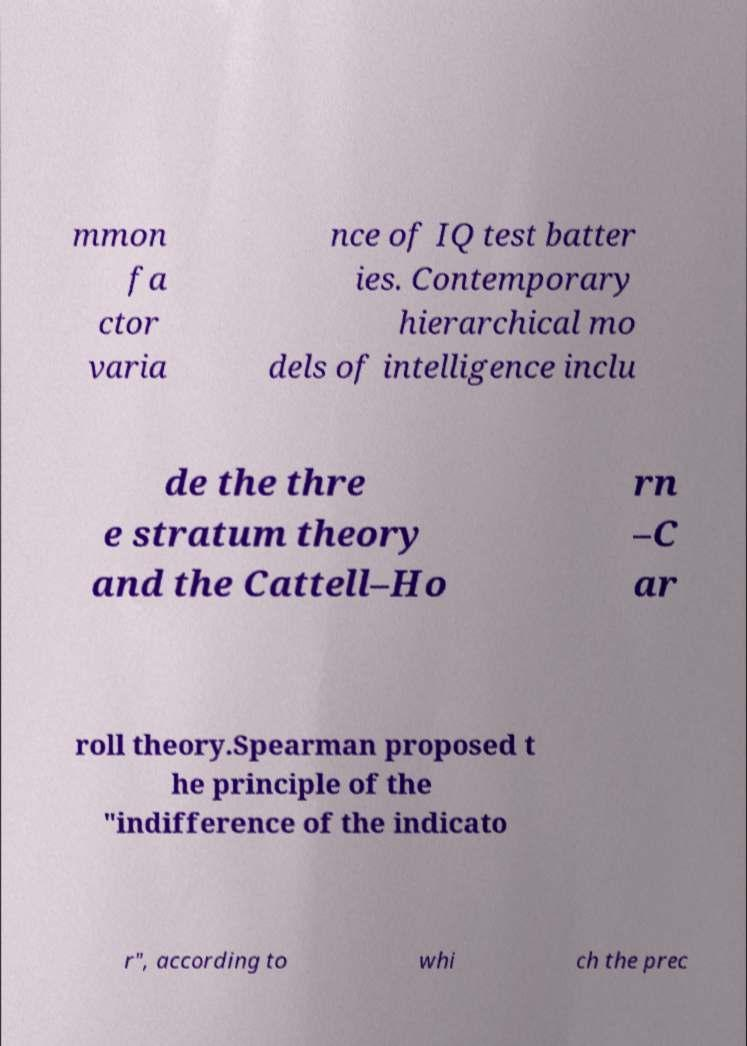For documentation purposes, I need the text within this image transcribed. Could you provide that? mmon fa ctor varia nce of IQ test batter ies. Contemporary hierarchical mo dels of intelligence inclu de the thre e stratum theory and the Cattell–Ho rn –C ar roll theory.Spearman proposed t he principle of the "indifference of the indicato r", according to whi ch the prec 